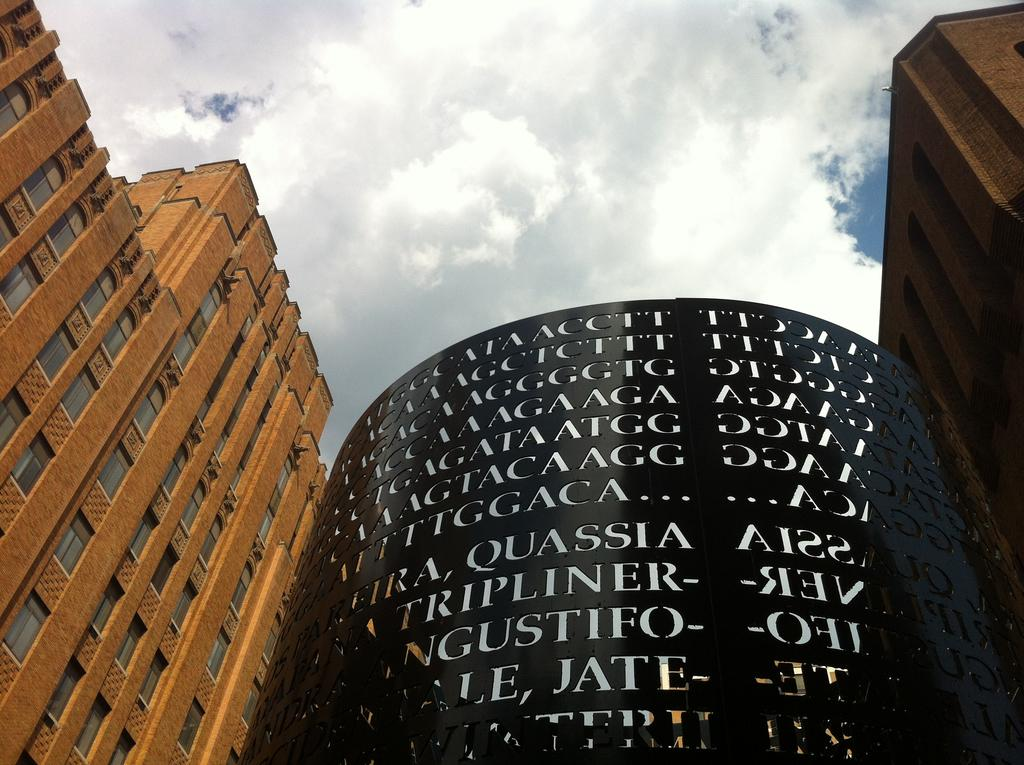What type of structures can be seen in the image? There are buildings in the image. Is there any text or writing visible on any of the buildings? Yes, there is something written on a black color building. What can be seen in the background of the image? The sky is visible in the background of the image. Can you tell me how many eggs are in the eggnog being served in the image? There is no eggnog or eggs present in the image; it only features buildings and writing on a black building. 